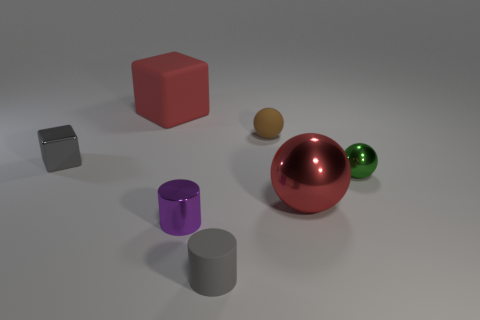Add 3 gray rubber things. How many objects exist? 10 Subtract all blocks. How many objects are left? 5 Subtract 0 yellow spheres. How many objects are left? 7 Subtract all tiny green metallic spheres. Subtract all tiny shiny things. How many objects are left? 3 Add 6 tiny purple objects. How many tiny purple objects are left? 7 Add 7 matte cubes. How many matte cubes exist? 8 